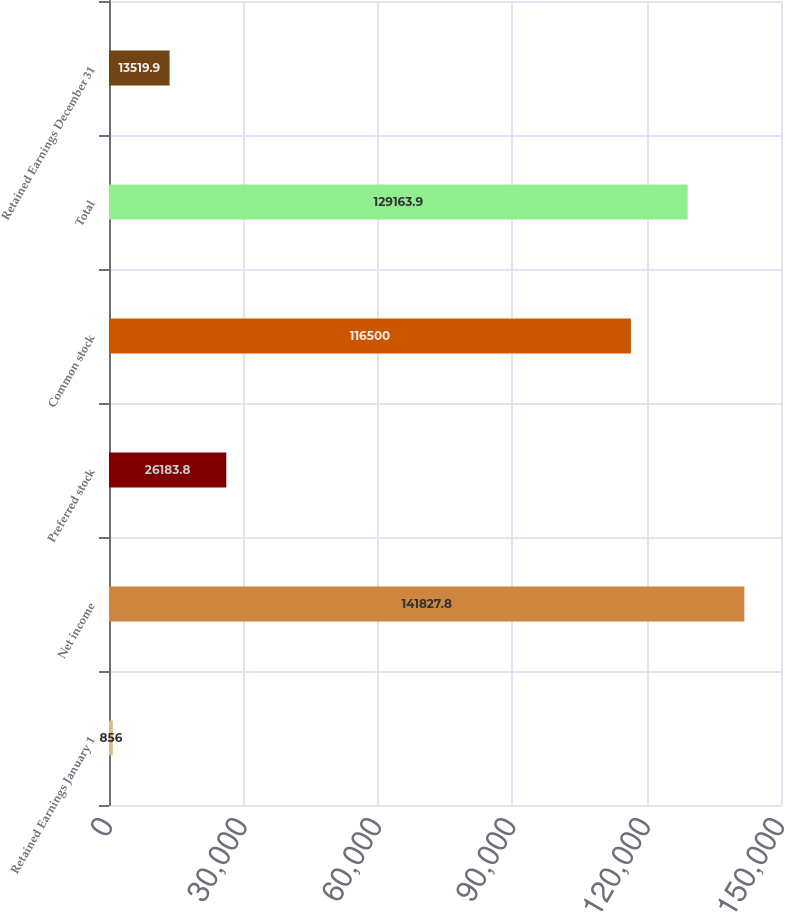Convert chart. <chart><loc_0><loc_0><loc_500><loc_500><bar_chart><fcel>Retained Earnings January 1<fcel>Net income<fcel>Preferred stock<fcel>Common stock<fcel>Total<fcel>Retained Earnings December 31<nl><fcel>856<fcel>141828<fcel>26183.8<fcel>116500<fcel>129164<fcel>13519.9<nl></chart> 